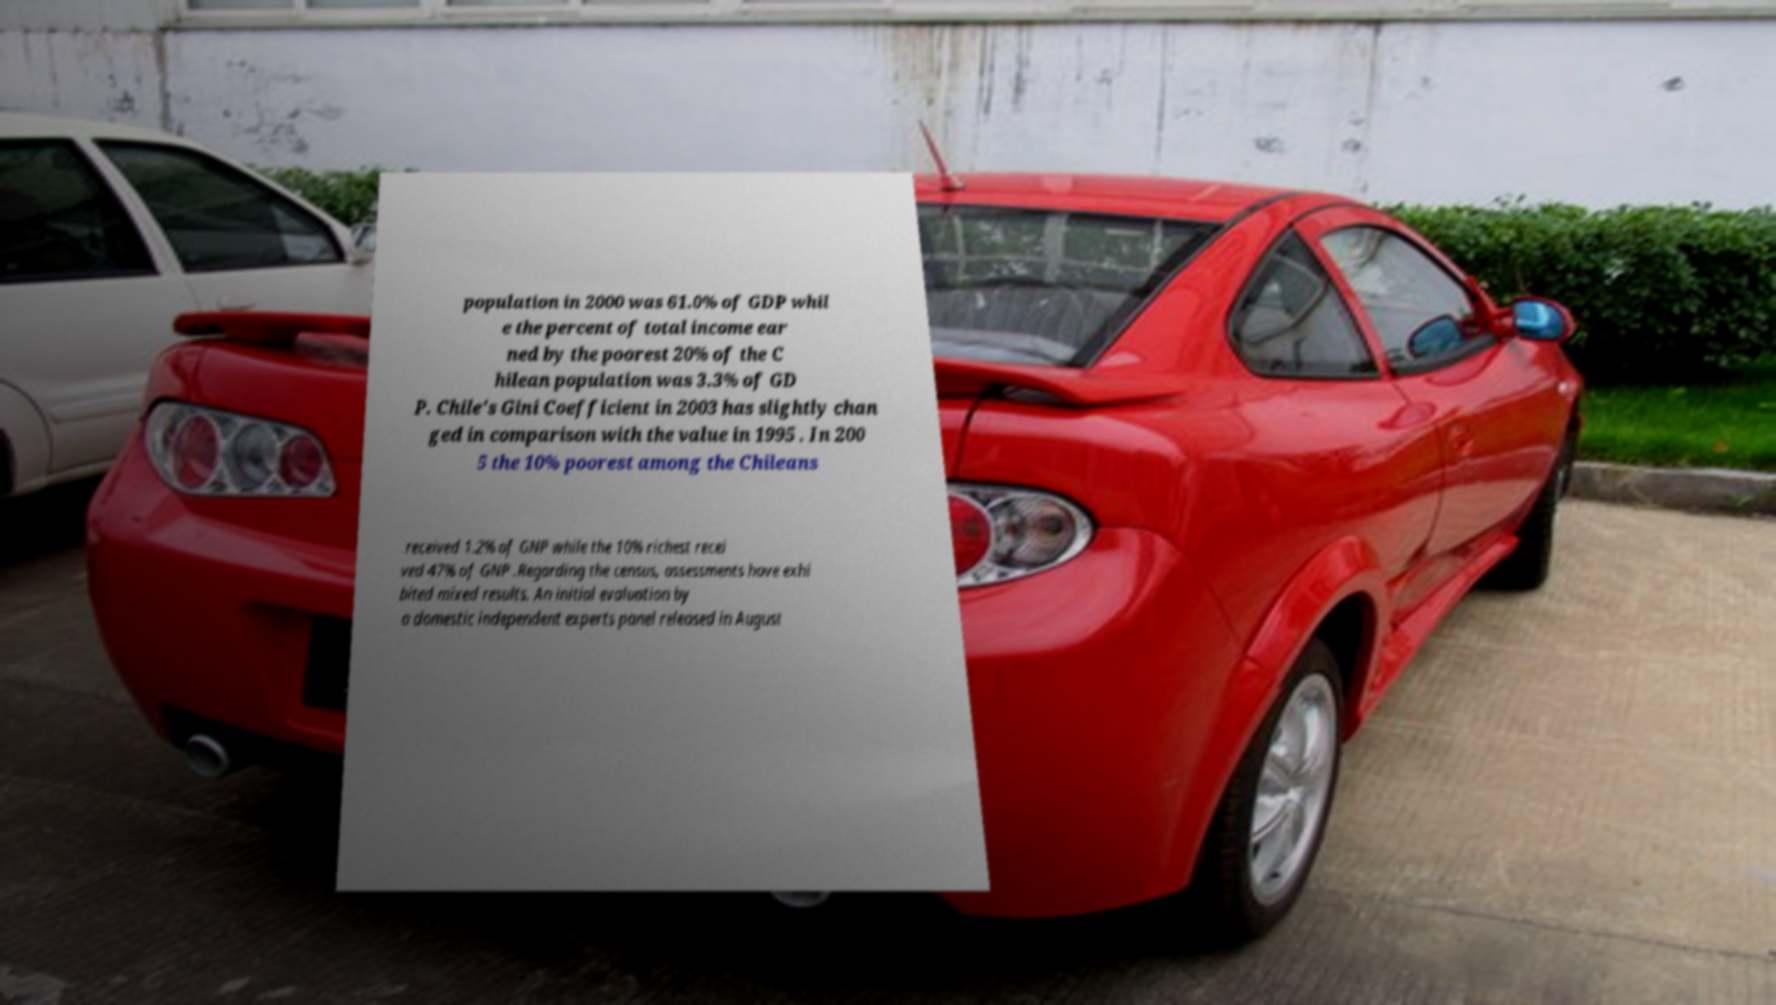Could you extract and type out the text from this image? population in 2000 was 61.0% of GDP whil e the percent of total income ear ned by the poorest 20% of the C hilean population was 3.3% of GD P. Chile's Gini Coefficient in 2003 has slightly chan ged in comparison with the value in 1995 . In 200 5 the 10% poorest among the Chileans received 1.2% of GNP while the 10% richest recei ved 47% of GNP .Regarding the census, assessments have exhi bited mixed results. An initial evaluation by a domestic independent experts panel released in August 